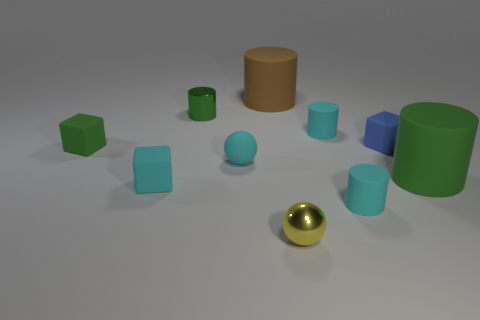Are there any large objects that have the same color as the tiny matte sphere? no 